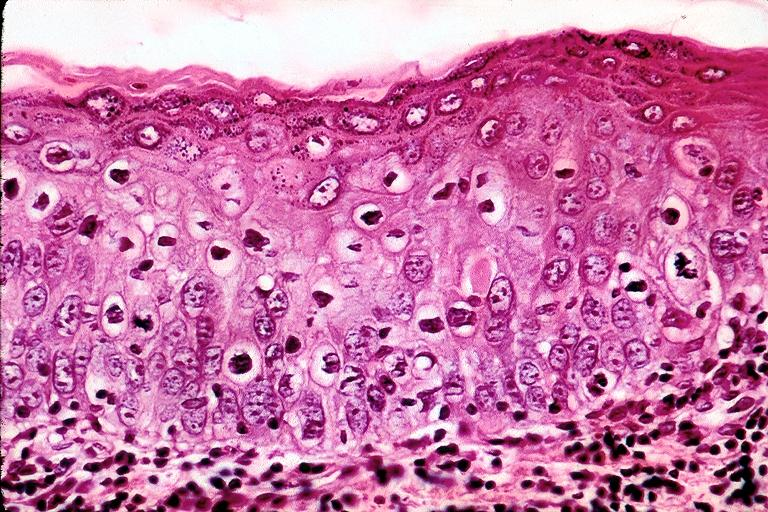what is present?
Answer the question using a single word or phrase. Oral 